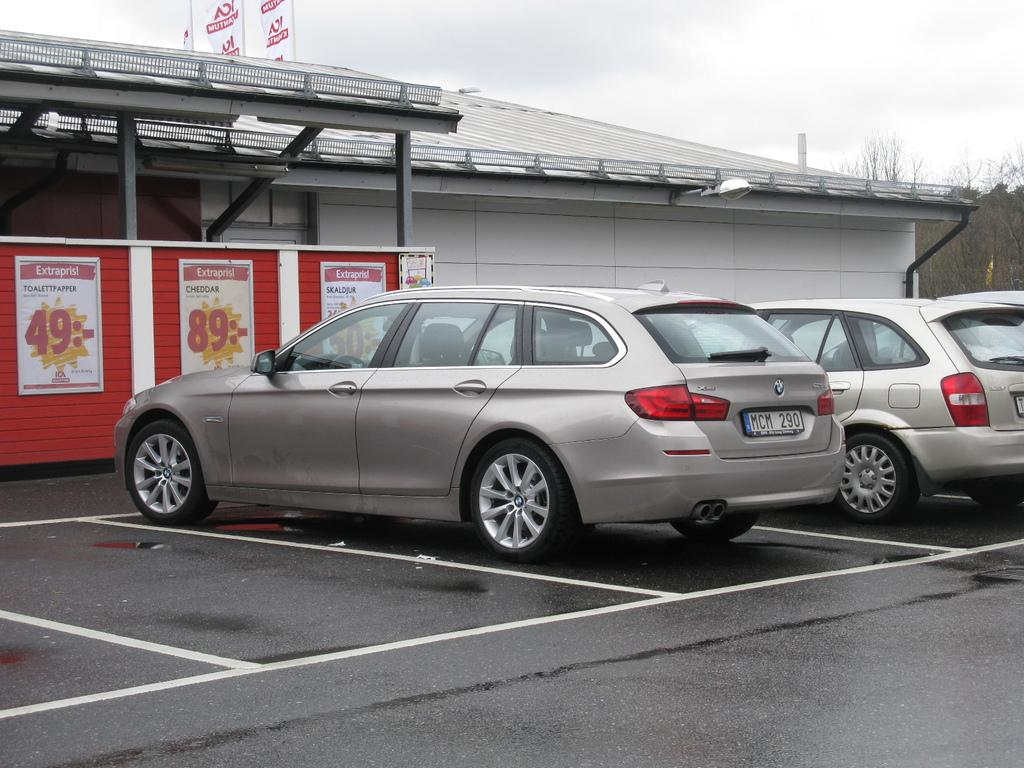What can be found in the parking area in the image? There are vehicles in the parking area in the image. What type of structure is present with poles in the image? There is a building with poles in the image. What kind of signage is visible in the image? There are posters in the image. What can be seen in the background of the image? The sky is visible in the background of the image. What purpose does the doll serve in the image? There is no doll present in the image, so it cannot serve any purpose in the image. Can you describe the kettle's design in the image? There is no kettle present in the image, so its design cannot be described. 